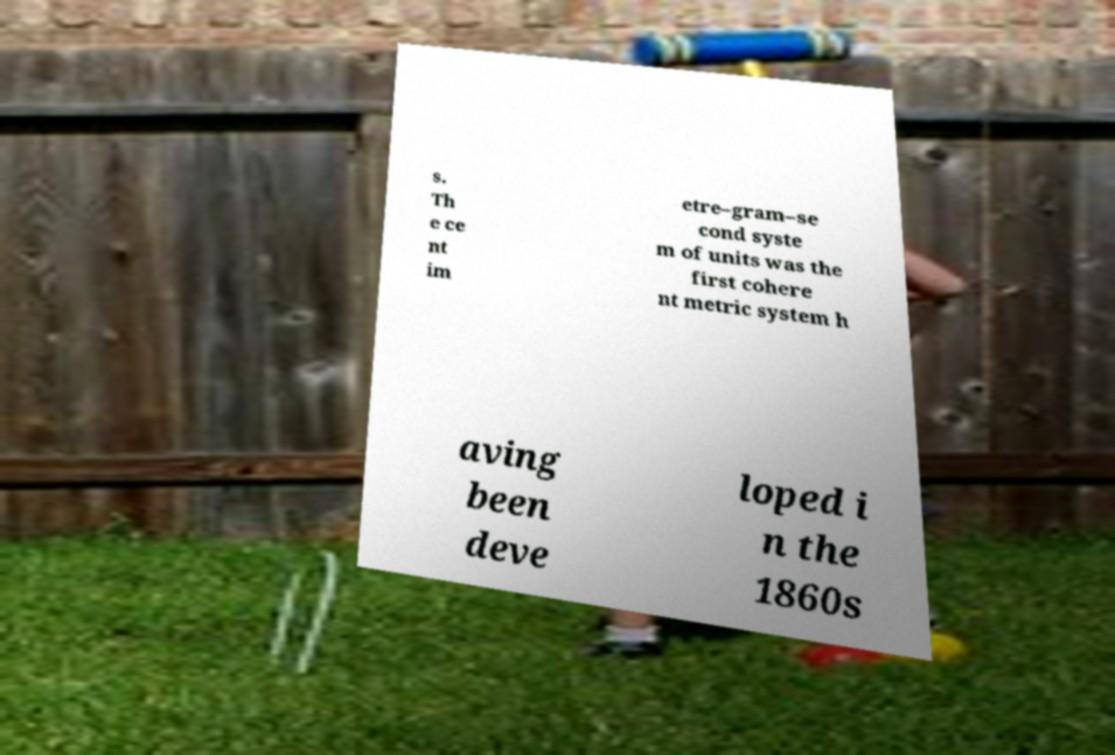There's text embedded in this image that I need extracted. Can you transcribe it verbatim? s. Th e ce nt im etre–gram–se cond syste m of units was the first cohere nt metric system h aving been deve loped i n the 1860s 